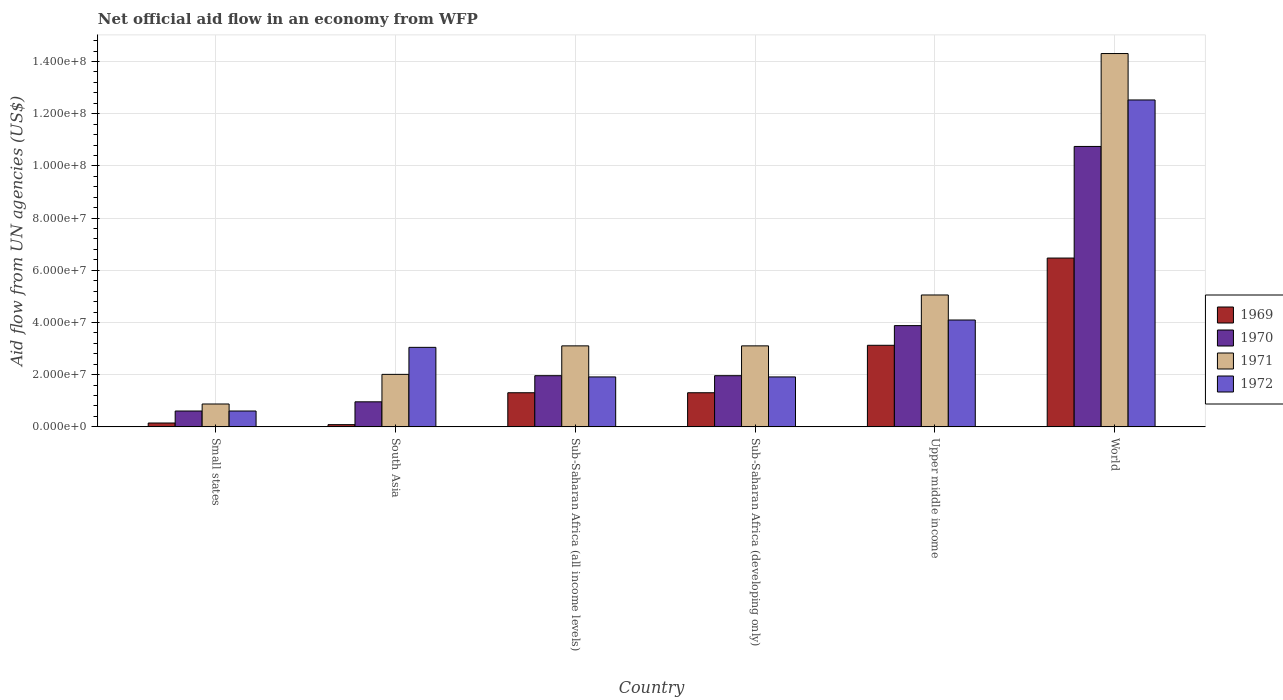How many different coloured bars are there?
Keep it short and to the point. 4. What is the label of the 4th group of bars from the left?
Provide a succinct answer. Sub-Saharan Africa (developing only). In how many cases, is the number of bars for a given country not equal to the number of legend labels?
Offer a very short reply. 0. What is the net official aid flow in 1970 in Sub-Saharan Africa (developing only)?
Provide a succinct answer. 1.96e+07. Across all countries, what is the maximum net official aid flow in 1971?
Offer a very short reply. 1.43e+08. Across all countries, what is the minimum net official aid flow in 1969?
Give a very brief answer. 8.50e+05. In which country was the net official aid flow in 1971 minimum?
Your answer should be compact. Small states. What is the total net official aid flow in 1971 in the graph?
Your response must be concise. 2.85e+08. What is the difference between the net official aid flow in 1971 in Sub-Saharan Africa (developing only) and that in Upper middle income?
Offer a terse response. -1.95e+07. What is the difference between the net official aid flow in 1971 in World and the net official aid flow in 1972 in Sub-Saharan Africa (developing only)?
Provide a succinct answer. 1.24e+08. What is the average net official aid flow in 1970 per country?
Make the answer very short. 3.35e+07. What is the difference between the net official aid flow of/in 1970 and net official aid flow of/in 1971 in World?
Give a very brief answer. -3.56e+07. In how many countries, is the net official aid flow in 1972 greater than 96000000 US$?
Offer a very short reply. 1. What is the ratio of the net official aid flow in 1972 in Small states to that in South Asia?
Give a very brief answer. 0.2. Is the net official aid flow in 1971 in Upper middle income less than that in World?
Offer a terse response. Yes. What is the difference between the highest and the second highest net official aid flow in 1969?
Keep it short and to the point. 3.34e+07. What is the difference between the highest and the lowest net official aid flow in 1972?
Provide a succinct answer. 1.19e+08. Is it the case that in every country, the sum of the net official aid flow in 1972 and net official aid flow in 1969 is greater than the sum of net official aid flow in 1970 and net official aid flow in 1971?
Offer a terse response. No. What does the 2nd bar from the left in Sub-Saharan Africa (all income levels) represents?
Your response must be concise. 1970. Is it the case that in every country, the sum of the net official aid flow in 1970 and net official aid flow in 1969 is greater than the net official aid flow in 1972?
Provide a succinct answer. No. How many bars are there?
Your response must be concise. 24. Are the values on the major ticks of Y-axis written in scientific E-notation?
Your response must be concise. Yes. How are the legend labels stacked?
Keep it short and to the point. Vertical. What is the title of the graph?
Offer a terse response. Net official aid flow in an economy from WFP. Does "1975" appear as one of the legend labels in the graph?
Provide a short and direct response. No. What is the label or title of the Y-axis?
Provide a succinct answer. Aid flow from UN agencies (US$). What is the Aid flow from UN agencies (US$) of 1969 in Small states?
Give a very brief answer. 1.48e+06. What is the Aid flow from UN agencies (US$) of 1970 in Small states?
Make the answer very short. 6.08e+06. What is the Aid flow from UN agencies (US$) in 1971 in Small states?
Provide a short and direct response. 8.77e+06. What is the Aid flow from UN agencies (US$) of 1972 in Small states?
Keep it short and to the point. 6.08e+06. What is the Aid flow from UN agencies (US$) in 1969 in South Asia?
Your answer should be compact. 8.50e+05. What is the Aid flow from UN agencies (US$) of 1970 in South Asia?
Your response must be concise. 9.60e+06. What is the Aid flow from UN agencies (US$) of 1971 in South Asia?
Provide a succinct answer. 2.01e+07. What is the Aid flow from UN agencies (US$) in 1972 in South Asia?
Provide a succinct answer. 3.05e+07. What is the Aid flow from UN agencies (US$) in 1969 in Sub-Saharan Africa (all income levels)?
Your response must be concise. 1.31e+07. What is the Aid flow from UN agencies (US$) of 1970 in Sub-Saharan Africa (all income levels)?
Your answer should be very brief. 1.96e+07. What is the Aid flow from UN agencies (US$) in 1971 in Sub-Saharan Africa (all income levels)?
Provide a short and direct response. 3.10e+07. What is the Aid flow from UN agencies (US$) of 1972 in Sub-Saharan Africa (all income levels)?
Offer a terse response. 1.91e+07. What is the Aid flow from UN agencies (US$) of 1969 in Sub-Saharan Africa (developing only)?
Make the answer very short. 1.31e+07. What is the Aid flow from UN agencies (US$) of 1970 in Sub-Saharan Africa (developing only)?
Make the answer very short. 1.96e+07. What is the Aid flow from UN agencies (US$) of 1971 in Sub-Saharan Africa (developing only)?
Provide a succinct answer. 3.10e+07. What is the Aid flow from UN agencies (US$) of 1972 in Sub-Saharan Africa (developing only)?
Make the answer very short. 1.91e+07. What is the Aid flow from UN agencies (US$) in 1969 in Upper middle income?
Provide a succinct answer. 3.13e+07. What is the Aid flow from UN agencies (US$) of 1970 in Upper middle income?
Offer a very short reply. 3.88e+07. What is the Aid flow from UN agencies (US$) in 1971 in Upper middle income?
Your answer should be compact. 5.05e+07. What is the Aid flow from UN agencies (US$) of 1972 in Upper middle income?
Make the answer very short. 4.10e+07. What is the Aid flow from UN agencies (US$) of 1969 in World?
Give a very brief answer. 6.47e+07. What is the Aid flow from UN agencies (US$) of 1970 in World?
Make the answer very short. 1.07e+08. What is the Aid flow from UN agencies (US$) in 1971 in World?
Your response must be concise. 1.43e+08. What is the Aid flow from UN agencies (US$) in 1972 in World?
Provide a succinct answer. 1.25e+08. Across all countries, what is the maximum Aid flow from UN agencies (US$) of 1969?
Ensure brevity in your answer.  6.47e+07. Across all countries, what is the maximum Aid flow from UN agencies (US$) of 1970?
Your answer should be compact. 1.07e+08. Across all countries, what is the maximum Aid flow from UN agencies (US$) in 1971?
Make the answer very short. 1.43e+08. Across all countries, what is the maximum Aid flow from UN agencies (US$) of 1972?
Your answer should be very brief. 1.25e+08. Across all countries, what is the minimum Aid flow from UN agencies (US$) in 1969?
Your answer should be compact. 8.50e+05. Across all countries, what is the minimum Aid flow from UN agencies (US$) of 1970?
Provide a succinct answer. 6.08e+06. Across all countries, what is the minimum Aid flow from UN agencies (US$) of 1971?
Your answer should be very brief. 8.77e+06. Across all countries, what is the minimum Aid flow from UN agencies (US$) in 1972?
Ensure brevity in your answer.  6.08e+06. What is the total Aid flow from UN agencies (US$) of 1969 in the graph?
Offer a terse response. 1.24e+08. What is the total Aid flow from UN agencies (US$) of 1970 in the graph?
Your response must be concise. 2.01e+08. What is the total Aid flow from UN agencies (US$) of 1971 in the graph?
Keep it short and to the point. 2.85e+08. What is the total Aid flow from UN agencies (US$) of 1972 in the graph?
Offer a very short reply. 2.41e+08. What is the difference between the Aid flow from UN agencies (US$) of 1969 in Small states and that in South Asia?
Ensure brevity in your answer.  6.30e+05. What is the difference between the Aid flow from UN agencies (US$) in 1970 in Small states and that in South Asia?
Give a very brief answer. -3.52e+06. What is the difference between the Aid flow from UN agencies (US$) in 1971 in Small states and that in South Asia?
Give a very brief answer. -1.14e+07. What is the difference between the Aid flow from UN agencies (US$) of 1972 in Small states and that in South Asia?
Give a very brief answer. -2.44e+07. What is the difference between the Aid flow from UN agencies (US$) in 1969 in Small states and that in Sub-Saharan Africa (all income levels)?
Give a very brief answer. -1.16e+07. What is the difference between the Aid flow from UN agencies (US$) of 1970 in Small states and that in Sub-Saharan Africa (all income levels)?
Make the answer very short. -1.35e+07. What is the difference between the Aid flow from UN agencies (US$) of 1971 in Small states and that in Sub-Saharan Africa (all income levels)?
Your response must be concise. -2.23e+07. What is the difference between the Aid flow from UN agencies (US$) of 1972 in Small states and that in Sub-Saharan Africa (all income levels)?
Offer a very short reply. -1.31e+07. What is the difference between the Aid flow from UN agencies (US$) of 1969 in Small states and that in Sub-Saharan Africa (developing only)?
Your answer should be compact. -1.16e+07. What is the difference between the Aid flow from UN agencies (US$) in 1970 in Small states and that in Sub-Saharan Africa (developing only)?
Give a very brief answer. -1.35e+07. What is the difference between the Aid flow from UN agencies (US$) of 1971 in Small states and that in Sub-Saharan Africa (developing only)?
Offer a terse response. -2.23e+07. What is the difference between the Aid flow from UN agencies (US$) in 1972 in Small states and that in Sub-Saharan Africa (developing only)?
Provide a succinct answer. -1.31e+07. What is the difference between the Aid flow from UN agencies (US$) of 1969 in Small states and that in Upper middle income?
Provide a succinct answer. -2.98e+07. What is the difference between the Aid flow from UN agencies (US$) in 1970 in Small states and that in Upper middle income?
Make the answer very short. -3.27e+07. What is the difference between the Aid flow from UN agencies (US$) of 1971 in Small states and that in Upper middle income?
Your answer should be compact. -4.18e+07. What is the difference between the Aid flow from UN agencies (US$) of 1972 in Small states and that in Upper middle income?
Provide a short and direct response. -3.49e+07. What is the difference between the Aid flow from UN agencies (US$) in 1969 in Small states and that in World?
Provide a short and direct response. -6.32e+07. What is the difference between the Aid flow from UN agencies (US$) in 1970 in Small states and that in World?
Offer a terse response. -1.01e+08. What is the difference between the Aid flow from UN agencies (US$) in 1971 in Small states and that in World?
Provide a succinct answer. -1.34e+08. What is the difference between the Aid flow from UN agencies (US$) of 1972 in Small states and that in World?
Your answer should be compact. -1.19e+08. What is the difference between the Aid flow from UN agencies (US$) in 1969 in South Asia and that in Sub-Saharan Africa (all income levels)?
Make the answer very short. -1.22e+07. What is the difference between the Aid flow from UN agencies (US$) of 1970 in South Asia and that in Sub-Saharan Africa (all income levels)?
Make the answer very short. -1.00e+07. What is the difference between the Aid flow from UN agencies (US$) in 1971 in South Asia and that in Sub-Saharan Africa (all income levels)?
Provide a short and direct response. -1.09e+07. What is the difference between the Aid flow from UN agencies (US$) in 1972 in South Asia and that in Sub-Saharan Africa (all income levels)?
Keep it short and to the point. 1.13e+07. What is the difference between the Aid flow from UN agencies (US$) of 1969 in South Asia and that in Sub-Saharan Africa (developing only)?
Your answer should be compact. -1.22e+07. What is the difference between the Aid flow from UN agencies (US$) of 1970 in South Asia and that in Sub-Saharan Africa (developing only)?
Your answer should be very brief. -1.00e+07. What is the difference between the Aid flow from UN agencies (US$) in 1971 in South Asia and that in Sub-Saharan Africa (developing only)?
Your answer should be very brief. -1.09e+07. What is the difference between the Aid flow from UN agencies (US$) in 1972 in South Asia and that in Sub-Saharan Africa (developing only)?
Your answer should be very brief. 1.13e+07. What is the difference between the Aid flow from UN agencies (US$) in 1969 in South Asia and that in Upper middle income?
Offer a terse response. -3.04e+07. What is the difference between the Aid flow from UN agencies (US$) of 1970 in South Asia and that in Upper middle income?
Offer a terse response. -2.92e+07. What is the difference between the Aid flow from UN agencies (US$) in 1971 in South Asia and that in Upper middle income?
Ensure brevity in your answer.  -3.04e+07. What is the difference between the Aid flow from UN agencies (US$) of 1972 in South Asia and that in Upper middle income?
Give a very brief answer. -1.05e+07. What is the difference between the Aid flow from UN agencies (US$) of 1969 in South Asia and that in World?
Offer a terse response. -6.38e+07. What is the difference between the Aid flow from UN agencies (US$) in 1970 in South Asia and that in World?
Your answer should be compact. -9.79e+07. What is the difference between the Aid flow from UN agencies (US$) of 1971 in South Asia and that in World?
Keep it short and to the point. -1.23e+08. What is the difference between the Aid flow from UN agencies (US$) of 1972 in South Asia and that in World?
Ensure brevity in your answer.  -9.48e+07. What is the difference between the Aid flow from UN agencies (US$) in 1969 in Sub-Saharan Africa (all income levels) and that in Sub-Saharan Africa (developing only)?
Your response must be concise. 0. What is the difference between the Aid flow from UN agencies (US$) of 1971 in Sub-Saharan Africa (all income levels) and that in Sub-Saharan Africa (developing only)?
Make the answer very short. 0. What is the difference between the Aid flow from UN agencies (US$) in 1969 in Sub-Saharan Africa (all income levels) and that in Upper middle income?
Offer a terse response. -1.82e+07. What is the difference between the Aid flow from UN agencies (US$) of 1970 in Sub-Saharan Africa (all income levels) and that in Upper middle income?
Ensure brevity in your answer.  -1.92e+07. What is the difference between the Aid flow from UN agencies (US$) of 1971 in Sub-Saharan Africa (all income levels) and that in Upper middle income?
Your response must be concise. -1.95e+07. What is the difference between the Aid flow from UN agencies (US$) in 1972 in Sub-Saharan Africa (all income levels) and that in Upper middle income?
Give a very brief answer. -2.18e+07. What is the difference between the Aid flow from UN agencies (US$) of 1969 in Sub-Saharan Africa (all income levels) and that in World?
Offer a terse response. -5.16e+07. What is the difference between the Aid flow from UN agencies (US$) of 1970 in Sub-Saharan Africa (all income levels) and that in World?
Your response must be concise. -8.78e+07. What is the difference between the Aid flow from UN agencies (US$) of 1971 in Sub-Saharan Africa (all income levels) and that in World?
Your answer should be compact. -1.12e+08. What is the difference between the Aid flow from UN agencies (US$) of 1972 in Sub-Saharan Africa (all income levels) and that in World?
Offer a terse response. -1.06e+08. What is the difference between the Aid flow from UN agencies (US$) of 1969 in Sub-Saharan Africa (developing only) and that in Upper middle income?
Offer a terse response. -1.82e+07. What is the difference between the Aid flow from UN agencies (US$) in 1970 in Sub-Saharan Africa (developing only) and that in Upper middle income?
Your answer should be very brief. -1.92e+07. What is the difference between the Aid flow from UN agencies (US$) in 1971 in Sub-Saharan Africa (developing only) and that in Upper middle income?
Keep it short and to the point. -1.95e+07. What is the difference between the Aid flow from UN agencies (US$) in 1972 in Sub-Saharan Africa (developing only) and that in Upper middle income?
Make the answer very short. -2.18e+07. What is the difference between the Aid flow from UN agencies (US$) in 1969 in Sub-Saharan Africa (developing only) and that in World?
Offer a very short reply. -5.16e+07. What is the difference between the Aid flow from UN agencies (US$) in 1970 in Sub-Saharan Africa (developing only) and that in World?
Provide a short and direct response. -8.78e+07. What is the difference between the Aid flow from UN agencies (US$) in 1971 in Sub-Saharan Africa (developing only) and that in World?
Make the answer very short. -1.12e+08. What is the difference between the Aid flow from UN agencies (US$) of 1972 in Sub-Saharan Africa (developing only) and that in World?
Provide a short and direct response. -1.06e+08. What is the difference between the Aid flow from UN agencies (US$) in 1969 in Upper middle income and that in World?
Keep it short and to the point. -3.34e+07. What is the difference between the Aid flow from UN agencies (US$) of 1970 in Upper middle income and that in World?
Make the answer very short. -6.87e+07. What is the difference between the Aid flow from UN agencies (US$) of 1971 in Upper middle income and that in World?
Keep it short and to the point. -9.25e+07. What is the difference between the Aid flow from UN agencies (US$) in 1972 in Upper middle income and that in World?
Offer a terse response. -8.43e+07. What is the difference between the Aid flow from UN agencies (US$) in 1969 in Small states and the Aid flow from UN agencies (US$) in 1970 in South Asia?
Your response must be concise. -8.12e+06. What is the difference between the Aid flow from UN agencies (US$) of 1969 in Small states and the Aid flow from UN agencies (US$) of 1971 in South Asia?
Your answer should be very brief. -1.86e+07. What is the difference between the Aid flow from UN agencies (US$) of 1969 in Small states and the Aid flow from UN agencies (US$) of 1972 in South Asia?
Offer a very short reply. -2.90e+07. What is the difference between the Aid flow from UN agencies (US$) of 1970 in Small states and the Aid flow from UN agencies (US$) of 1971 in South Asia?
Give a very brief answer. -1.40e+07. What is the difference between the Aid flow from UN agencies (US$) in 1970 in Small states and the Aid flow from UN agencies (US$) in 1972 in South Asia?
Make the answer very short. -2.44e+07. What is the difference between the Aid flow from UN agencies (US$) in 1971 in Small states and the Aid flow from UN agencies (US$) in 1972 in South Asia?
Your answer should be very brief. -2.17e+07. What is the difference between the Aid flow from UN agencies (US$) in 1969 in Small states and the Aid flow from UN agencies (US$) in 1970 in Sub-Saharan Africa (all income levels)?
Your response must be concise. -1.81e+07. What is the difference between the Aid flow from UN agencies (US$) in 1969 in Small states and the Aid flow from UN agencies (US$) in 1971 in Sub-Saharan Africa (all income levels)?
Ensure brevity in your answer.  -2.96e+07. What is the difference between the Aid flow from UN agencies (US$) in 1969 in Small states and the Aid flow from UN agencies (US$) in 1972 in Sub-Saharan Africa (all income levels)?
Offer a very short reply. -1.77e+07. What is the difference between the Aid flow from UN agencies (US$) of 1970 in Small states and the Aid flow from UN agencies (US$) of 1971 in Sub-Saharan Africa (all income levels)?
Provide a succinct answer. -2.50e+07. What is the difference between the Aid flow from UN agencies (US$) of 1970 in Small states and the Aid flow from UN agencies (US$) of 1972 in Sub-Saharan Africa (all income levels)?
Ensure brevity in your answer.  -1.31e+07. What is the difference between the Aid flow from UN agencies (US$) in 1971 in Small states and the Aid flow from UN agencies (US$) in 1972 in Sub-Saharan Africa (all income levels)?
Your answer should be very brief. -1.04e+07. What is the difference between the Aid flow from UN agencies (US$) of 1969 in Small states and the Aid flow from UN agencies (US$) of 1970 in Sub-Saharan Africa (developing only)?
Your answer should be compact. -1.81e+07. What is the difference between the Aid flow from UN agencies (US$) in 1969 in Small states and the Aid flow from UN agencies (US$) in 1971 in Sub-Saharan Africa (developing only)?
Offer a very short reply. -2.96e+07. What is the difference between the Aid flow from UN agencies (US$) of 1969 in Small states and the Aid flow from UN agencies (US$) of 1972 in Sub-Saharan Africa (developing only)?
Your answer should be compact. -1.77e+07. What is the difference between the Aid flow from UN agencies (US$) of 1970 in Small states and the Aid flow from UN agencies (US$) of 1971 in Sub-Saharan Africa (developing only)?
Provide a short and direct response. -2.50e+07. What is the difference between the Aid flow from UN agencies (US$) in 1970 in Small states and the Aid flow from UN agencies (US$) in 1972 in Sub-Saharan Africa (developing only)?
Provide a succinct answer. -1.31e+07. What is the difference between the Aid flow from UN agencies (US$) in 1971 in Small states and the Aid flow from UN agencies (US$) in 1972 in Sub-Saharan Africa (developing only)?
Ensure brevity in your answer.  -1.04e+07. What is the difference between the Aid flow from UN agencies (US$) in 1969 in Small states and the Aid flow from UN agencies (US$) in 1970 in Upper middle income?
Offer a very short reply. -3.73e+07. What is the difference between the Aid flow from UN agencies (US$) of 1969 in Small states and the Aid flow from UN agencies (US$) of 1971 in Upper middle income?
Keep it short and to the point. -4.91e+07. What is the difference between the Aid flow from UN agencies (US$) in 1969 in Small states and the Aid flow from UN agencies (US$) in 1972 in Upper middle income?
Make the answer very short. -3.95e+07. What is the difference between the Aid flow from UN agencies (US$) in 1970 in Small states and the Aid flow from UN agencies (US$) in 1971 in Upper middle income?
Give a very brief answer. -4.45e+07. What is the difference between the Aid flow from UN agencies (US$) in 1970 in Small states and the Aid flow from UN agencies (US$) in 1972 in Upper middle income?
Give a very brief answer. -3.49e+07. What is the difference between the Aid flow from UN agencies (US$) of 1971 in Small states and the Aid flow from UN agencies (US$) of 1972 in Upper middle income?
Provide a succinct answer. -3.22e+07. What is the difference between the Aid flow from UN agencies (US$) in 1969 in Small states and the Aid flow from UN agencies (US$) in 1970 in World?
Provide a short and direct response. -1.06e+08. What is the difference between the Aid flow from UN agencies (US$) of 1969 in Small states and the Aid flow from UN agencies (US$) of 1971 in World?
Keep it short and to the point. -1.42e+08. What is the difference between the Aid flow from UN agencies (US$) in 1969 in Small states and the Aid flow from UN agencies (US$) in 1972 in World?
Offer a very short reply. -1.24e+08. What is the difference between the Aid flow from UN agencies (US$) in 1970 in Small states and the Aid flow from UN agencies (US$) in 1971 in World?
Give a very brief answer. -1.37e+08. What is the difference between the Aid flow from UN agencies (US$) of 1970 in Small states and the Aid flow from UN agencies (US$) of 1972 in World?
Keep it short and to the point. -1.19e+08. What is the difference between the Aid flow from UN agencies (US$) of 1971 in Small states and the Aid flow from UN agencies (US$) of 1972 in World?
Provide a succinct answer. -1.16e+08. What is the difference between the Aid flow from UN agencies (US$) of 1969 in South Asia and the Aid flow from UN agencies (US$) of 1970 in Sub-Saharan Africa (all income levels)?
Your answer should be very brief. -1.88e+07. What is the difference between the Aid flow from UN agencies (US$) of 1969 in South Asia and the Aid flow from UN agencies (US$) of 1971 in Sub-Saharan Africa (all income levels)?
Offer a very short reply. -3.02e+07. What is the difference between the Aid flow from UN agencies (US$) of 1969 in South Asia and the Aid flow from UN agencies (US$) of 1972 in Sub-Saharan Africa (all income levels)?
Ensure brevity in your answer.  -1.83e+07. What is the difference between the Aid flow from UN agencies (US$) of 1970 in South Asia and the Aid flow from UN agencies (US$) of 1971 in Sub-Saharan Africa (all income levels)?
Make the answer very short. -2.14e+07. What is the difference between the Aid flow from UN agencies (US$) of 1970 in South Asia and the Aid flow from UN agencies (US$) of 1972 in Sub-Saharan Africa (all income levels)?
Provide a succinct answer. -9.54e+06. What is the difference between the Aid flow from UN agencies (US$) in 1971 in South Asia and the Aid flow from UN agencies (US$) in 1972 in Sub-Saharan Africa (all income levels)?
Your answer should be very brief. 9.80e+05. What is the difference between the Aid flow from UN agencies (US$) in 1969 in South Asia and the Aid flow from UN agencies (US$) in 1970 in Sub-Saharan Africa (developing only)?
Offer a very short reply. -1.88e+07. What is the difference between the Aid flow from UN agencies (US$) in 1969 in South Asia and the Aid flow from UN agencies (US$) in 1971 in Sub-Saharan Africa (developing only)?
Offer a terse response. -3.02e+07. What is the difference between the Aid flow from UN agencies (US$) in 1969 in South Asia and the Aid flow from UN agencies (US$) in 1972 in Sub-Saharan Africa (developing only)?
Keep it short and to the point. -1.83e+07. What is the difference between the Aid flow from UN agencies (US$) in 1970 in South Asia and the Aid flow from UN agencies (US$) in 1971 in Sub-Saharan Africa (developing only)?
Give a very brief answer. -2.14e+07. What is the difference between the Aid flow from UN agencies (US$) of 1970 in South Asia and the Aid flow from UN agencies (US$) of 1972 in Sub-Saharan Africa (developing only)?
Your response must be concise. -9.54e+06. What is the difference between the Aid flow from UN agencies (US$) in 1971 in South Asia and the Aid flow from UN agencies (US$) in 1972 in Sub-Saharan Africa (developing only)?
Offer a terse response. 9.80e+05. What is the difference between the Aid flow from UN agencies (US$) in 1969 in South Asia and the Aid flow from UN agencies (US$) in 1970 in Upper middle income?
Keep it short and to the point. -3.79e+07. What is the difference between the Aid flow from UN agencies (US$) of 1969 in South Asia and the Aid flow from UN agencies (US$) of 1971 in Upper middle income?
Provide a short and direct response. -4.97e+07. What is the difference between the Aid flow from UN agencies (US$) in 1969 in South Asia and the Aid flow from UN agencies (US$) in 1972 in Upper middle income?
Your response must be concise. -4.01e+07. What is the difference between the Aid flow from UN agencies (US$) of 1970 in South Asia and the Aid flow from UN agencies (US$) of 1971 in Upper middle income?
Ensure brevity in your answer.  -4.09e+07. What is the difference between the Aid flow from UN agencies (US$) of 1970 in South Asia and the Aid flow from UN agencies (US$) of 1972 in Upper middle income?
Your answer should be very brief. -3.14e+07. What is the difference between the Aid flow from UN agencies (US$) in 1971 in South Asia and the Aid flow from UN agencies (US$) in 1972 in Upper middle income?
Offer a very short reply. -2.08e+07. What is the difference between the Aid flow from UN agencies (US$) of 1969 in South Asia and the Aid flow from UN agencies (US$) of 1970 in World?
Offer a very short reply. -1.07e+08. What is the difference between the Aid flow from UN agencies (US$) of 1969 in South Asia and the Aid flow from UN agencies (US$) of 1971 in World?
Provide a short and direct response. -1.42e+08. What is the difference between the Aid flow from UN agencies (US$) of 1969 in South Asia and the Aid flow from UN agencies (US$) of 1972 in World?
Provide a short and direct response. -1.24e+08. What is the difference between the Aid flow from UN agencies (US$) in 1970 in South Asia and the Aid flow from UN agencies (US$) in 1971 in World?
Ensure brevity in your answer.  -1.33e+08. What is the difference between the Aid flow from UN agencies (US$) in 1970 in South Asia and the Aid flow from UN agencies (US$) in 1972 in World?
Provide a succinct answer. -1.16e+08. What is the difference between the Aid flow from UN agencies (US$) in 1971 in South Asia and the Aid flow from UN agencies (US$) in 1972 in World?
Your response must be concise. -1.05e+08. What is the difference between the Aid flow from UN agencies (US$) of 1969 in Sub-Saharan Africa (all income levels) and the Aid flow from UN agencies (US$) of 1970 in Sub-Saharan Africa (developing only)?
Offer a terse response. -6.53e+06. What is the difference between the Aid flow from UN agencies (US$) of 1969 in Sub-Saharan Africa (all income levels) and the Aid flow from UN agencies (US$) of 1971 in Sub-Saharan Africa (developing only)?
Your answer should be very brief. -1.80e+07. What is the difference between the Aid flow from UN agencies (US$) in 1969 in Sub-Saharan Africa (all income levels) and the Aid flow from UN agencies (US$) in 1972 in Sub-Saharan Africa (developing only)?
Your response must be concise. -6.06e+06. What is the difference between the Aid flow from UN agencies (US$) of 1970 in Sub-Saharan Africa (all income levels) and the Aid flow from UN agencies (US$) of 1971 in Sub-Saharan Africa (developing only)?
Provide a short and direct response. -1.14e+07. What is the difference between the Aid flow from UN agencies (US$) of 1971 in Sub-Saharan Africa (all income levels) and the Aid flow from UN agencies (US$) of 1972 in Sub-Saharan Africa (developing only)?
Offer a very short reply. 1.19e+07. What is the difference between the Aid flow from UN agencies (US$) in 1969 in Sub-Saharan Africa (all income levels) and the Aid flow from UN agencies (US$) in 1970 in Upper middle income?
Your answer should be compact. -2.57e+07. What is the difference between the Aid flow from UN agencies (US$) of 1969 in Sub-Saharan Africa (all income levels) and the Aid flow from UN agencies (US$) of 1971 in Upper middle income?
Your answer should be compact. -3.75e+07. What is the difference between the Aid flow from UN agencies (US$) in 1969 in Sub-Saharan Africa (all income levels) and the Aid flow from UN agencies (US$) in 1972 in Upper middle income?
Provide a succinct answer. -2.79e+07. What is the difference between the Aid flow from UN agencies (US$) of 1970 in Sub-Saharan Africa (all income levels) and the Aid flow from UN agencies (US$) of 1971 in Upper middle income?
Your answer should be very brief. -3.09e+07. What is the difference between the Aid flow from UN agencies (US$) of 1970 in Sub-Saharan Africa (all income levels) and the Aid flow from UN agencies (US$) of 1972 in Upper middle income?
Give a very brief answer. -2.13e+07. What is the difference between the Aid flow from UN agencies (US$) in 1971 in Sub-Saharan Africa (all income levels) and the Aid flow from UN agencies (US$) in 1972 in Upper middle income?
Your answer should be very brief. -9.91e+06. What is the difference between the Aid flow from UN agencies (US$) of 1969 in Sub-Saharan Africa (all income levels) and the Aid flow from UN agencies (US$) of 1970 in World?
Your response must be concise. -9.44e+07. What is the difference between the Aid flow from UN agencies (US$) in 1969 in Sub-Saharan Africa (all income levels) and the Aid flow from UN agencies (US$) in 1971 in World?
Offer a terse response. -1.30e+08. What is the difference between the Aid flow from UN agencies (US$) in 1969 in Sub-Saharan Africa (all income levels) and the Aid flow from UN agencies (US$) in 1972 in World?
Offer a terse response. -1.12e+08. What is the difference between the Aid flow from UN agencies (US$) of 1970 in Sub-Saharan Africa (all income levels) and the Aid flow from UN agencies (US$) of 1971 in World?
Make the answer very short. -1.23e+08. What is the difference between the Aid flow from UN agencies (US$) of 1970 in Sub-Saharan Africa (all income levels) and the Aid flow from UN agencies (US$) of 1972 in World?
Offer a terse response. -1.06e+08. What is the difference between the Aid flow from UN agencies (US$) in 1971 in Sub-Saharan Africa (all income levels) and the Aid flow from UN agencies (US$) in 1972 in World?
Offer a terse response. -9.42e+07. What is the difference between the Aid flow from UN agencies (US$) of 1969 in Sub-Saharan Africa (developing only) and the Aid flow from UN agencies (US$) of 1970 in Upper middle income?
Provide a succinct answer. -2.57e+07. What is the difference between the Aid flow from UN agencies (US$) of 1969 in Sub-Saharan Africa (developing only) and the Aid flow from UN agencies (US$) of 1971 in Upper middle income?
Keep it short and to the point. -3.75e+07. What is the difference between the Aid flow from UN agencies (US$) in 1969 in Sub-Saharan Africa (developing only) and the Aid flow from UN agencies (US$) in 1972 in Upper middle income?
Offer a very short reply. -2.79e+07. What is the difference between the Aid flow from UN agencies (US$) in 1970 in Sub-Saharan Africa (developing only) and the Aid flow from UN agencies (US$) in 1971 in Upper middle income?
Offer a very short reply. -3.09e+07. What is the difference between the Aid flow from UN agencies (US$) in 1970 in Sub-Saharan Africa (developing only) and the Aid flow from UN agencies (US$) in 1972 in Upper middle income?
Keep it short and to the point. -2.13e+07. What is the difference between the Aid flow from UN agencies (US$) of 1971 in Sub-Saharan Africa (developing only) and the Aid flow from UN agencies (US$) of 1972 in Upper middle income?
Your response must be concise. -9.91e+06. What is the difference between the Aid flow from UN agencies (US$) of 1969 in Sub-Saharan Africa (developing only) and the Aid flow from UN agencies (US$) of 1970 in World?
Offer a terse response. -9.44e+07. What is the difference between the Aid flow from UN agencies (US$) in 1969 in Sub-Saharan Africa (developing only) and the Aid flow from UN agencies (US$) in 1971 in World?
Ensure brevity in your answer.  -1.30e+08. What is the difference between the Aid flow from UN agencies (US$) in 1969 in Sub-Saharan Africa (developing only) and the Aid flow from UN agencies (US$) in 1972 in World?
Offer a very short reply. -1.12e+08. What is the difference between the Aid flow from UN agencies (US$) in 1970 in Sub-Saharan Africa (developing only) and the Aid flow from UN agencies (US$) in 1971 in World?
Keep it short and to the point. -1.23e+08. What is the difference between the Aid flow from UN agencies (US$) of 1970 in Sub-Saharan Africa (developing only) and the Aid flow from UN agencies (US$) of 1972 in World?
Offer a very short reply. -1.06e+08. What is the difference between the Aid flow from UN agencies (US$) of 1971 in Sub-Saharan Africa (developing only) and the Aid flow from UN agencies (US$) of 1972 in World?
Give a very brief answer. -9.42e+07. What is the difference between the Aid flow from UN agencies (US$) in 1969 in Upper middle income and the Aid flow from UN agencies (US$) in 1970 in World?
Give a very brief answer. -7.62e+07. What is the difference between the Aid flow from UN agencies (US$) in 1969 in Upper middle income and the Aid flow from UN agencies (US$) in 1971 in World?
Give a very brief answer. -1.12e+08. What is the difference between the Aid flow from UN agencies (US$) in 1969 in Upper middle income and the Aid flow from UN agencies (US$) in 1972 in World?
Your answer should be very brief. -9.40e+07. What is the difference between the Aid flow from UN agencies (US$) in 1970 in Upper middle income and the Aid flow from UN agencies (US$) in 1971 in World?
Your answer should be compact. -1.04e+08. What is the difference between the Aid flow from UN agencies (US$) in 1970 in Upper middle income and the Aid flow from UN agencies (US$) in 1972 in World?
Make the answer very short. -8.65e+07. What is the difference between the Aid flow from UN agencies (US$) of 1971 in Upper middle income and the Aid flow from UN agencies (US$) of 1972 in World?
Your answer should be very brief. -7.47e+07. What is the average Aid flow from UN agencies (US$) in 1969 per country?
Offer a terse response. 2.07e+07. What is the average Aid flow from UN agencies (US$) in 1970 per country?
Your answer should be very brief. 3.35e+07. What is the average Aid flow from UN agencies (US$) of 1971 per country?
Offer a terse response. 4.74e+07. What is the average Aid flow from UN agencies (US$) of 1972 per country?
Your answer should be compact. 4.02e+07. What is the difference between the Aid flow from UN agencies (US$) in 1969 and Aid flow from UN agencies (US$) in 1970 in Small states?
Ensure brevity in your answer.  -4.60e+06. What is the difference between the Aid flow from UN agencies (US$) in 1969 and Aid flow from UN agencies (US$) in 1971 in Small states?
Ensure brevity in your answer.  -7.29e+06. What is the difference between the Aid flow from UN agencies (US$) in 1969 and Aid flow from UN agencies (US$) in 1972 in Small states?
Provide a succinct answer. -4.60e+06. What is the difference between the Aid flow from UN agencies (US$) of 1970 and Aid flow from UN agencies (US$) of 1971 in Small states?
Offer a terse response. -2.69e+06. What is the difference between the Aid flow from UN agencies (US$) in 1970 and Aid flow from UN agencies (US$) in 1972 in Small states?
Give a very brief answer. 0. What is the difference between the Aid flow from UN agencies (US$) of 1971 and Aid flow from UN agencies (US$) of 1972 in Small states?
Give a very brief answer. 2.69e+06. What is the difference between the Aid flow from UN agencies (US$) of 1969 and Aid flow from UN agencies (US$) of 1970 in South Asia?
Provide a succinct answer. -8.75e+06. What is the difference between the Aid flow from UN agencies (US$) in 1969 and Aid flow from UN agencies (US$) in 1971 in South Asia?
Your answer should be compact. -1.93e+07. What is the difference between the Aid flow from UN agencies (US$) in 1969 and Aid flow from UN agencies (US$) in 1972 in South Asia?
Your answer should be very brief. -2.96e+07. What is the difference between the Aid flow from UN agencies (US$) in 1970 and Aid flow from UN agencies (US$) in 1971 in South Asia?
Your response must be concise. -1.05e+07. What is the difference between the Aid flow from UN agencies (US$) of 1970 and Aid flow from UN agencies (US$) of 1972 in South Asia?
Provide a short and direct response. -2.09e+07. What is the difference between the Aid flow from UN agencies (US$) of 1971 and Aid flow from UN agencies (US$) of 1972 in South Asia?
Provide a succinct answer. -1.04e+07. What is the difference between the Aid flow from UN agencies (US$) in 1969 and Aid flow from UN agencies (US$) in 1970 in Sub-Saharan Africa (all income levels)?
Offer a terse response. -6.53e+06. What is the difference between the Aid flow from UN agencies (US$) of 1969 and Aid flow from UN agencies (US$) of 1971 in Sub-Saharan Africa (all income levels)?
Offer a very short reply. -1.80e+07. What is the difference between the Aid flow from UN agencies (US$) of 1969 and Aid flow from UN agencies (US$) of 1972 in Sub-Saharan Africa (all income levels)?
Ensure brevity in your answer.  -6.06e+06. What is the difference between the Aid flow from UN agencies (US$) of 1970 and Aid flow from UN agencies (US$) of 1971 in Sub-Saharan Africa (all income levels)?
Provide a succinct answer. -1.14e+07. What is the difference between the Aid flow from UN agencies (US$) in 1971 and Aid flow from UN agencies (US$) in 1972 in Sub-Saharan Africa (all income levels)?
Provide a succinct answer. 1.19e+07. What is the difference between the Aid flow from UN agencies (US$) of 1969 and Aid flow from UN agencies (US$) of 1970 in Sub-Saharan Africa (developing only)?
Your answer should be very brief. -6.53e+06. What is the difference between the Aid flow from UN agencies (US$) in 1969 and Aid flow from UN agencies (US$) in 1971 in Sub-Saharan Africa (developing only)?
Your answer should be very brief. -1.80e+07. What is the difference between the Aid flow from UN agencies (US$) of 1969 and Aid flow from UN agencies (US$) of 1972 in Sub-Saharan Africa (developing only)?
Provide a succinct answer. -6.06e+06. What is the difference between the Aid flow from UN agencies (US$) in 1970 and Aid flow from UN agencies (US$) in 1971 in Sub-Saharan Africa (developing only)?
Your answer should be very brief. -1.14e+07. What is the difference between the Aid flow from UN agencies (US$) in 1971 and Aid flow from UN agencies (US$) in 1972 in Sub-Saharan Africa (developing only)?
Ensure brevity in your answer.  1.19e+07. What is the difference between the Aid flow from UN agencies (US$) in 1969 and Aid flow from UN agencies (US$) in 1970 in Upper middle income?
Your answer should be compact. -7.54e+06. What is the difference between the Aid flow from UN agencies (US$) in 1969 and Aid flow from UN agencies (US$) in 1971 in Upper middle income?
Provide a short and direct response. -1.93e+07. What is the difference between the Aid flow from UN agencies (US$) of 1969 and Aid flow from UN agencies (US$) of 1972 in Upper middle income?
Give a very brief answer. -9.69e+06. What is the difference between the Aid flow from UN agencies (US$) in 1970 and Aid flow from UN agencies (US$) in 1971 in Upper middle income?
Ensure brevity in your answer.  -1.17e+07. What is the difference between the Aid flow from UN agencies (US$) of 1970 and Aid flow from UN agencies (US$) of 1972 in Upper middle income?
Provide a succinct answer. -2.15e+06. What is the difference between the Aid flow from UN agencies (US$) of 1971 and Aid flow from UN agencies (US$) of 1972 in Upper middle income?
Offer a very short reply. 9.59e+06. What is the difference between the Aid flow from UN agencies (US$) of 1969 and Aid flow from UN agencies (US$) of 1970 in World?
Your response must be concise. -4.28e+07. What is the difference between the Aid flow from UN agencies (US$) of 1969 and Aid flow from UN agencies (US$) of 1971 in World?
Make the answer very short. -7.84e+07. What is the difference between the Aid flow from UN agencies (US$) of 1969 and Aid flow from UN agencies (US$) of 1972 in World?
Provide a short and direct response. -6.06e+07. What is the difference between the Aid flow from UN agencies (US$) of 1970 and Aid flow from UN agencies (US$) of 1971 in World?
Ensure brevity in your answer.  -3.56e+07. What is the difference between the Aid flow from UN agencies (US$) of 1970 and Aid flow from UN agencies (US$) of 1972 in World?
Give a very brief answer. -1.78e+07. What is the difference between the Aid flow from UN agencies (US$) in 1971 and Aid flow from UN agencies (US$) in 1972 in World?
Provide a short and direct response. 1.78e+07. What is the ratio of the Aid flow from UN agencies (US$) of 1969 in Small states to that in South Asia?
Your response must be concise. 1.74. What is the ratio of the Aid flow from UN agencies (US$) in 1970 in Small states to that in South Asia?
Offer a terse response. 0.63. What is the ratio of the Aid flow from UN agencies (US$) in 1971 in Small states to that in South Asia?
Offer a terse response. 0.44. What is the ratio of the Aid flow from UN agencies (US$) of 1972 in Small states to that in South Asia?
Keep it short and to the point. 0.2. What is the ratio of the Aid flow from UN agencies (US$) in 1969 in Small states to that in Sub-Saharan Africa (all income levels)?
Provide a short and direct response. 0.11. What is the ratio of the Aid flow from UN agencies (US$) of 1970 in Small states to that in Sub-Saharan Africa (all income levels)?
Offer a terse response. 0.31. What is the ratio of the Aid flow from UN agencies (US$) of 1971 in Small states to that in Sub-Saharan Africa (all income levels)?
Offer a terse response. 0.28. What is the ratio of the Aid flow from UN agencies (US$) of 1972 in Small states to that in Sub-Saharan Africa (all income levels)?
Offer a very short reply. 0.32. What is the ratio of the Aid flow from UN agencies (US$) in 1969 in Small states to that in Sub-Saharan Africa (developing only)?
Your answer should be very brief. 0.11. What is the ratio of the Aid flow from UN agencies (US$) of 1970 in Small states to that in Sub-Saharan Africa (developing only)?
Ensure brevity in your answer.  0.31. What is the ratio of the Aid flow from UN agencies (US$) of 1971 in Small states to that in Sub-Saharan Africa (developing only)?
Make the answer very short. 0.28. What is the ratio of the Aid flow from UN agencies (US$) in 1972 in Small states to that in Sub-Saharan Africa (developing only)?
Your answer should be compact. 0.32. What is the ratio of the Aid flow from UN agencies (US$) in 1969 in Small states to that in Upper middle income?
Your answer should be very brief. 0.05. What is the ratio of the Aid flow from UN agencies (US$) in 1970 in Small states to that in Upper middle income?
Keep it short and to the point. 0.16. What is the ratio of the Aid flow from UN agencies (US$) of 1971 in Small states to that in Upper middle income?
Offer a terse response. 0.17. What is the ratio of the Aid flow from UN agencies (US$) of 1972 in Small states to that in Upper middle income?
Ensure brevity in your answer.  0.15. What is the ratio of the Aid flow from UN agencies (US$) in 1969 in Small states to that in World?
Your response must be concise. 0.02. What is the ratio of the Aid flow from UN agencies (US$) in 1970 in Small states to that in World?
Your answer should be compact. 0.06. What is the ratio of the Aid flow from UN agencies (US$) in 1971 in Small states to that in World?
Your answer should be very brief. 0.06. What is the ratio of the Aid flow from UN agencies (US$) of 1972 in Small states to that in World?
Provide a succinct answer. 0.05. What is the ratio of the Aid flow from UN agencies (US$) in 1969 in South Asia to that in Sub-Saharan Africa (all income levels)?
Your answer should be compact. 0.07. What is the ratio of the Aid flow from UN agencies (US$) in 1970 in South Asia to that in Sub-Saharan Africa (all income levels)?
Ensure brevity in your answer.  0.49. What is the ratio of the Aid flow from UN agencies (US$) of 1971 in South Asia to that in Sub-Saharan Africa (all income levels)?
Offer a terse response. 0.65. What is the ratio of the Aid flow from UN agencies (US$) of 1972 in South Asia to that in Sub-Saharan Africa (all income levels)?
Provide a short and direct response. 1.59. What is the ratio of the Aid flow from UN agencies (US$) in 1969 in South Asia to that in Sub-Saharan Africa (developing only)?
Offer a terse response. 0.07. What is the ratio of the Aid flow from UN agencies (US$) of 1970 in South Asia to that in Sub-Saharan Africa (developing only)?
Provide a succinct answer. 0.49. What is the ratio of the Aid flow from UN agencies (US$) of 1971 in South Asia to that in Sub-Saharan Africa (developing only)?
Make the answer very short. 0.65. What is the ratio of the Aid flow from UN agencies (US$) in 1972 in South Asia to that in Sub-Saharan Africa (developing only)?
Your answer should be very brief. 1.59. What is the ratio of the Aid flow from UN agencies (US$) of 1969 in South Asia to that in Upper middle income?
Provide a short and direct response. 0.03. What is the ratio of the Aid flow from UN agencies (US$) in 1970 in South Asia to that in Upper middle income?
Provide a succinct answer. 0.25. What is the ratio of the Aid flow from UN agencies (US$) in 1971 in South Asia to that in Upper middle income?
Provide a short and direct response. 0.4. What is the ratio of the Aid flow from UN agencies (US$) in 1972 in South Asia to that in Upper middle income?
Keep it short and to the point. 0.74. What is the ratio of the Aid flow from UN agencies (US$) in 1969 in South Asia to that in World?
Provide a succinct answer. 0.01. What is the ratio of the Aid flow from UN agencies (US$) of 1970 in South Asia to that in World?
Your answer should be very brief. 0.09. What is the ratio of the Aid flow from UN agencies (US$) of 1971 in South Asia to that in World?
Your answer should be compact. 0.14. What is the ratio of the Aid flow from UN agencies (US$) of 1972 in South Asia to that in World?
Your response must be concise. 0.24. What is the ratio of the Aid flow from UN agencies (US$) of 1969 in Sub-Saharan Africa (all income levels) to that in Upper middle income?
Offer a very short reply. 0.42. What is the ratio of the Aid flow from UN agencies (US$) of 1970 in Sub-Saharan Africa (all income levels) to that in Upper middle income?
Your answer should be compact. 0.51. What is the ratio of the Aid flow from UN agencies (US$) in 1971 in Sub-Saharan Africa (all income levels) to that in Upper middle income?
Offer a terse response. 0.61. What is the ratio of the Aid flow from UN agencies (US$) in 1972 in Sub-Saharan Africa (all income levels) to that in Upper middle income?
Keep it short and to the point. 0.47. What is the ratio of the Aid flow from UN agencies (US$) in 1969 in Sub-Saharan Africa (all income levels) to that in World?
Ensure brevity in your answer.  0.2. What is the ratio of the Aid flow from UN agencies (US$) in 1970 in Sub-Saharan Africa (all income levels) to that in World?
Offer a very short reply. 0.18. What is the ratio of the Aid flow from UN agencies (US$) of 1971 in Sub-Saharan Africa (all income levels) to that in World?
Your answer should be compact. 0.22. What is the ratio of the Aid flow from UN agencies (US$) of 1972 in Sub-Saharan Africa (all income levels) to that in World?
Give a very brief answer. 0.15. What is the ratio of the Aid flow from UN agencies (US$) in 1969 in Sub-Saharan Africa (developing only) to that in Upper middle income?
Your response must be concise. 0.42. What is the ratio of the Aid flow from UN agencies (US$) of 1970 in Sub-Saharan Africa (developing only) to that in Upper middle income?
Offer a very short reply. 0.51. What is the ratio of the Aid flow from UN agencies (US$) in 1971 in Sub-Saharan Africa (developing only) to that in Upper middle income?
Your answer should be very brief. 0.61. What is the ratio of the Aid flow from UN agencies (US$) of 1972 in Sub-Saharan Africa (developing only) to that in Upper middle income?
Your answer should be very brief. 0.47. What is the ratio of the Aid flow from UN agencies (US$) of 1969 in Sub-Saharan Africa (developing only) to that in World?
Provide a succinct answer. 0.2. What is the ratio of the Aid flow from UN agencies (US$) of 1970 in Sub-Saharan Africa (developing only) to that in World?
Offer a very short reply. 0.18. What is the ratio of the Aid flow from UN agencies (US$) of 1971 in Sub-Saharan Africa (developing only) to that in World?
Provide a succinct answer. 0.22. What is the ratio of the Aid flow from UN agencies (US$) of 1972 in Sub-Saharan Africa (developing only) to that in World?
Offer a very short reply. 0.15. What is the ratio of the Aid flow from UN agencies (US$) of 1969 in Upper middle income to that in World?
Provide a short and direct response. 0.48. What is the ratio of the Aid flow from UN agencies (US$) of 1970 in Upper middle income to that in World?
Your response must be concise. 0.36. What is the ratio of the Aid flow from UN agencies (US$) in 1971 in Upper middle income to that in World?
Ensure brevity in your answer.  0.35. What is the ratio of the Aid flow from UN agencies (US$) in 1972 in Upper middle income to that in World?
Keep it short and to the point. 0.33. What is the difference between the highest and the second highest Aid flow from UN agencies (US$) in 1969?
Keep it short and to the point. 3.34e+07. What is the difference between the highest and the second highest Aid flow from UN agencies (US$) of 1970?
Ensure brevity in your answer.  6.87e+07. What is the difference between the highest and the second highest Aid flow from UN agencies (US$) in 1971?
Provide a succinct answer. 9.25e+07. What is the difference between the highest and the second highest Aid flow from UN agencies (US$) of 1972?
Provide a succinct answer. 8.43e+07. What is the difference between the highest and the lowest Aid flow from UN agencies (US$) of 1969?
Offer a terse response. 6.38e+07. What is the difference between the highest and the lowest Aid flow from UN agencies (US$) in 1970?
Give a very brief answer. 1.01e+08. What is the difference between the highest and the lowest Aid flow from UN agencies (US$) of 1971?
Provide a succinct answer. 1.34e+08. What is the difference between the highest and the lowest Aid flow from UN agencies (US$) of 1972?
Provide a short and direct response. 1.19e+08. 